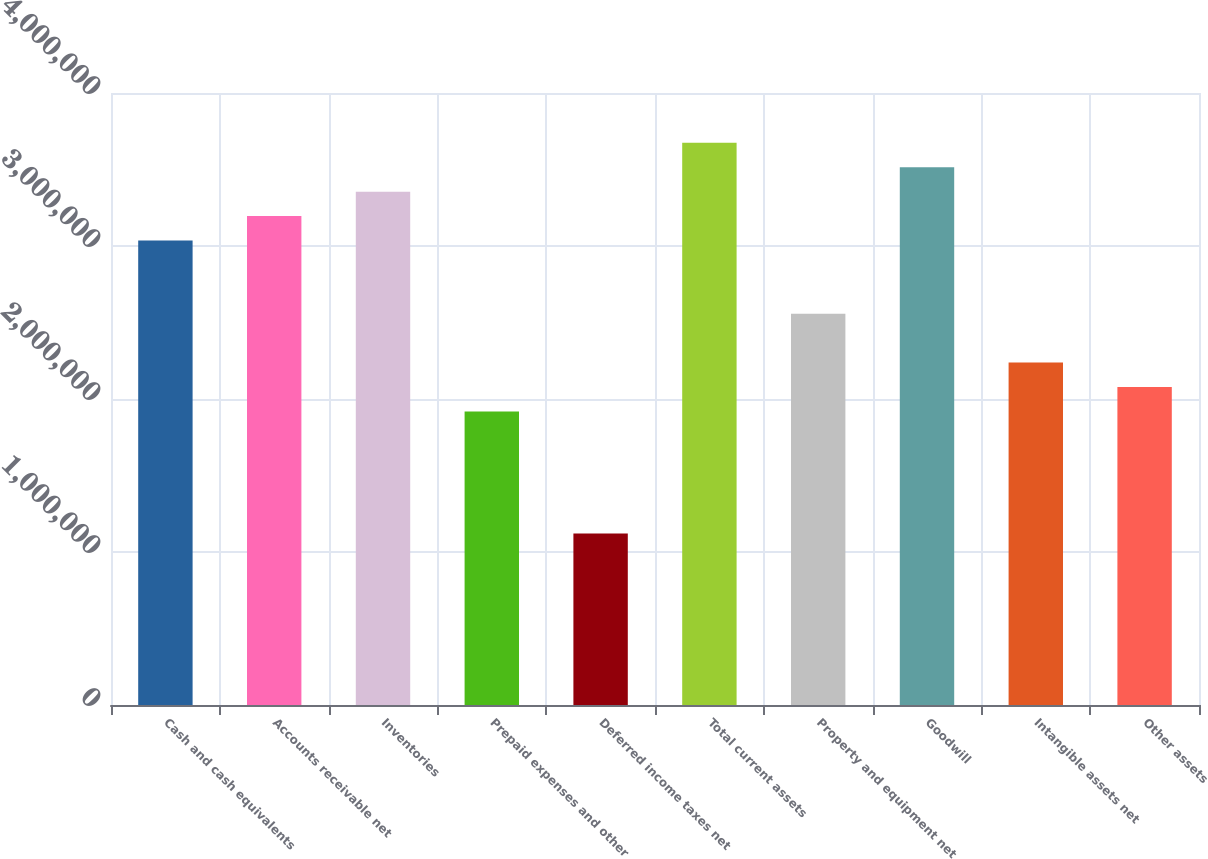Convert chart. <chart><loc_0><loc_0><loc_500><loc_500><bar_chart><fcel>Cash and cash equivalents<fcel>Accounts receivable net<fcel>Inventories<fcel>Prepaid expenses and other<fcel>Deferred income taxes net<fcel>Total current assets<fcel>Property and equipment net<fcel>Goodwill<fcel>Intangible assets net<fcel>Other assets<nl><fcel>3.03591e+06<fcel>3.19547e+06<fcel>3.35503e+06<fcel>1.91902e+06<fcel>1.12123e+06<fcel>3.67414e+06<fcel>2.55724e+06<fcel>3.51458e+06<fcel>2.23813e+06<fcel>2.07857e+06<nl></chart> 